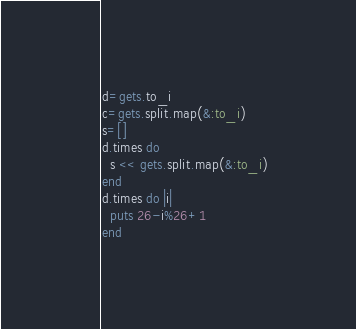<code> <loc_0><loc_0><loc_500><loc_500><_Ruby_>d=gets.to_i
c=gets.split.map(&:to_i)
s=[]
d.times do
  s << gets.split.map(&:to_i)
end
d.times do |i|
  puts 26-i%26+1
end
</code> 